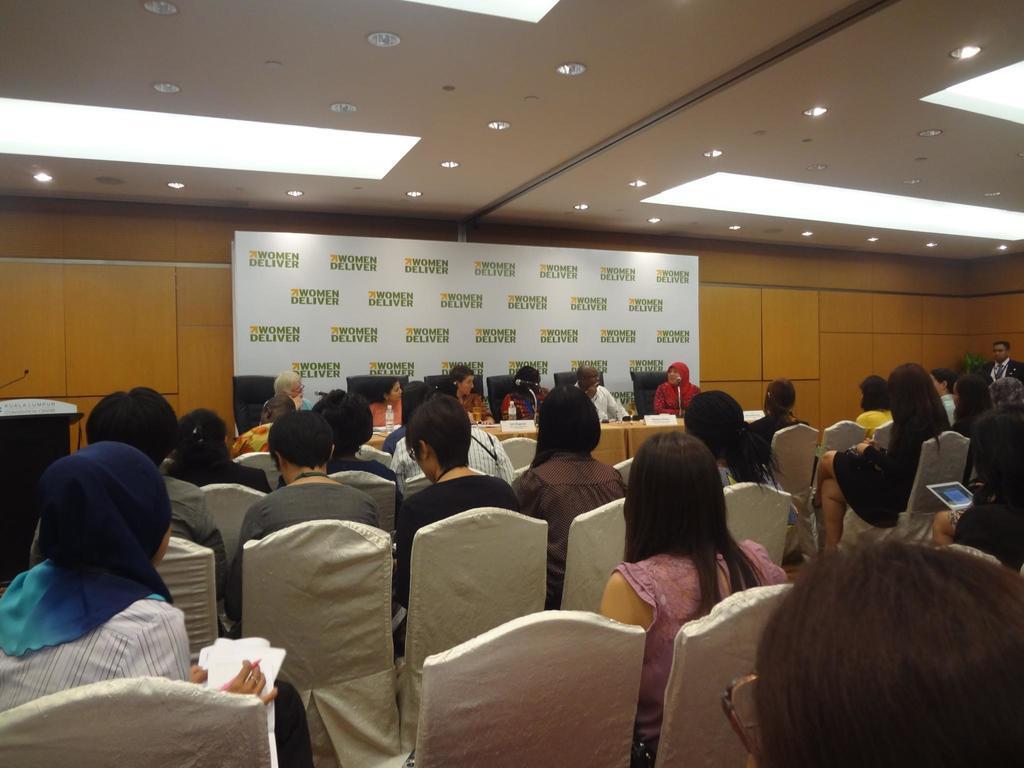How would you summarize this image in a sentence or two? In this picture we can see a group of people are sitting on chairs and in front of the people there is a table and on the table there are bottles, name boards and microphones. Behind the people there is a board and on the top there are ceiling lights. 